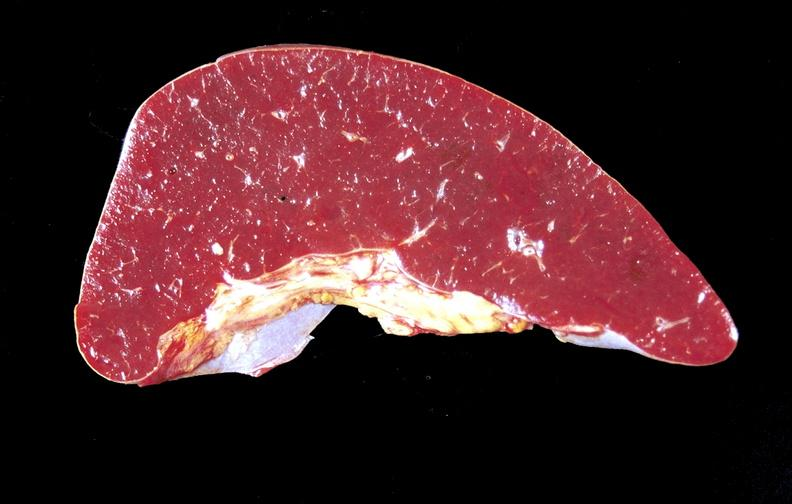what is present?
Answer the question using a single word or phrase. Hematologic 